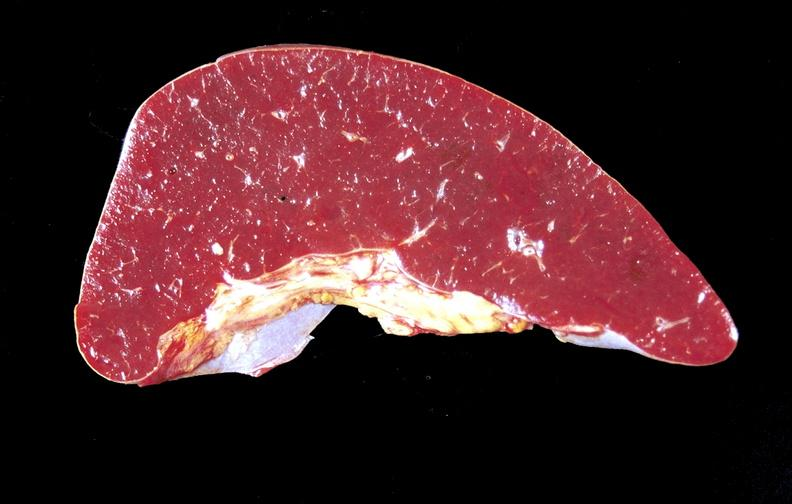what is present?
Answer the question using a single word or phrase. Hematologic 